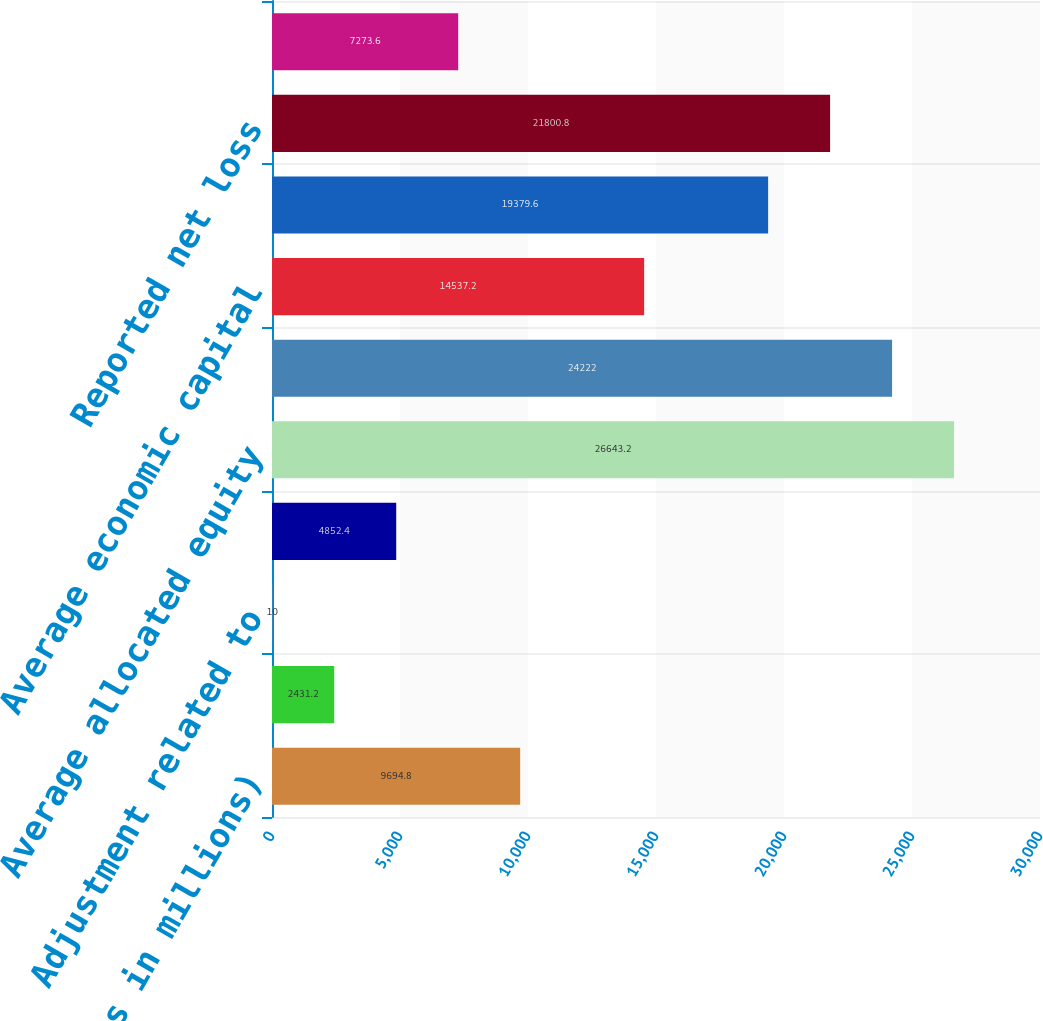Convert chart. <chart><loc_0><loc_0><loc_500><loc_500><bar_chart><fcel>(Dollars in millions)<fcel>Reported net income<fcel>Adjustment related to<fcel>Adjusted net income<fcel>Average allocated equity<fcel>Adjustment related to goodwill<fcel>Average economic capital<fcel>Reported net income (loss)<fcel>Reported net loss<fcel>Goodwill impairment charges<nl><fcel>9694.8<fcel>2431.2<fcel>10<fcel>4852.4<fcel>26643.2<fcel>24222<fcel>14537.2<fcel>19379.6<fcel>21800.8<fcel>7273.6<nl></chart> 